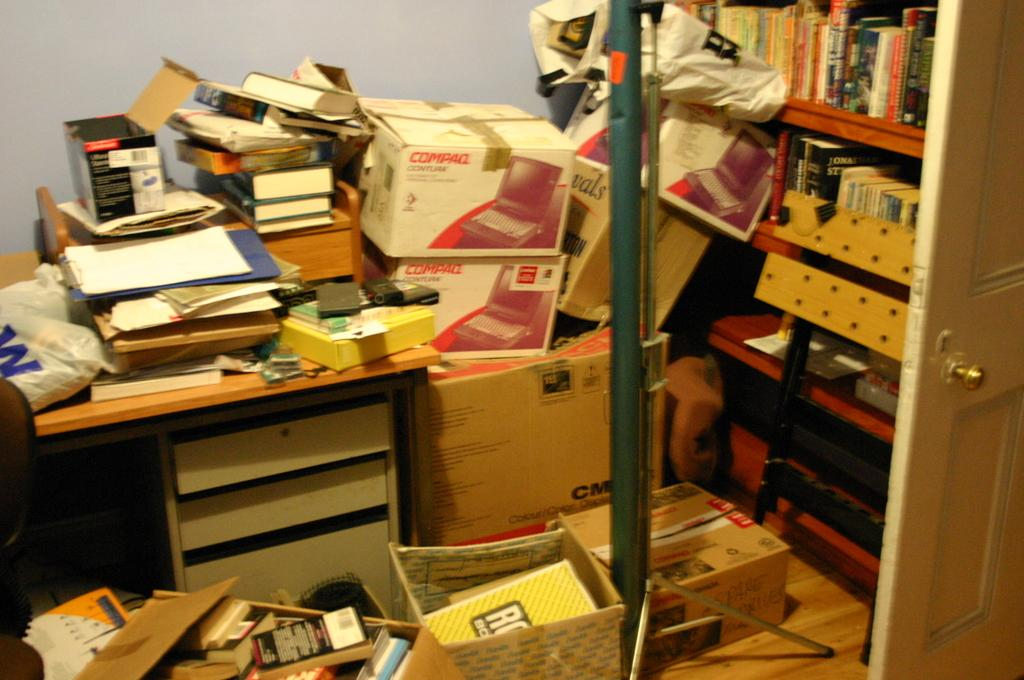<image>
Write a terse but informative summary of the picture. A messy office space with Compaq boxes stacked up. 